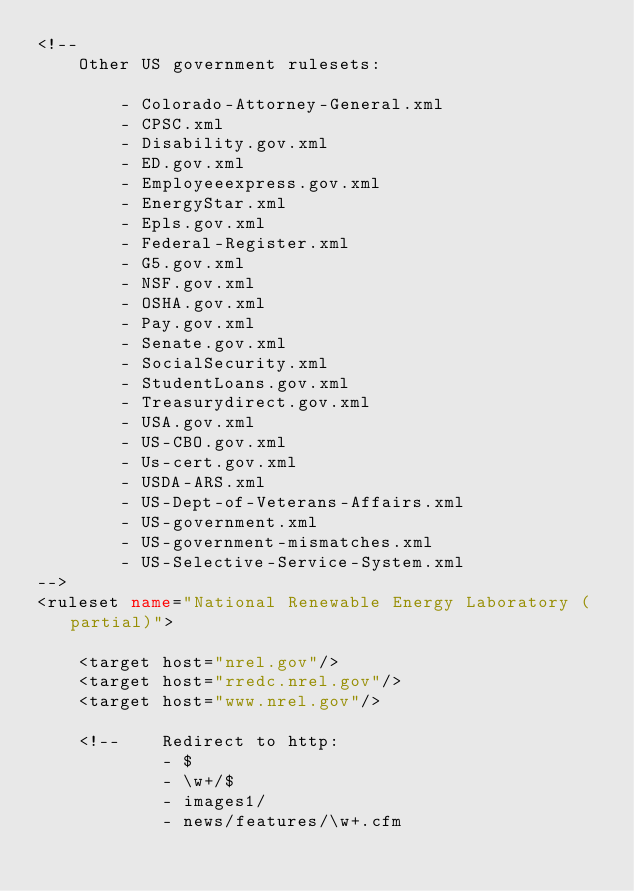Convert code to text. <code><loc_0><loc_0><loc_500><loc_500><_XML_><!--
	Other US government rulesets:

		- Colorado-Attorney-General.xml
		- CPSC.xml
		- Disability.gov.xml
		- ED.gov.xml
		- Employeeexpress.gov.xml
		- EnergyStar.xml
		- Epls.gov.xml
		- Federal-Register.xml
		- G5.gov.xml
		- NSF.gov.xml
		- OSHA.gov.xml
		- Pay.gov.xml
		- Senate.gov.xml
		- SocialSecurity.xml
		- StudentLoans.gov.xml
		- Treasurydirect.gov.xml
		- USA.gov.xml
		- US-CBO.gov.xml
		- Us-cert.gov.xml
		- USDA-ARS.xml
		- US-Dept-of-Veterans-Affairs.xml
		- US-government.xml
		- US-government-mismatches.xml
		- US-Selective-Service-System.xml
-->
<ruleset name="National Renewable Energy Laboratory (partial)">

	<target host="nrel.gov"/>
	<target host="rredc.nrel.gov"/>
	<target host="www.nrel.gov"/>

	<!--	Redirect to http:
			- $
			- \w+/$
			- images1/
			- news/features/\w+.cfm</code> 